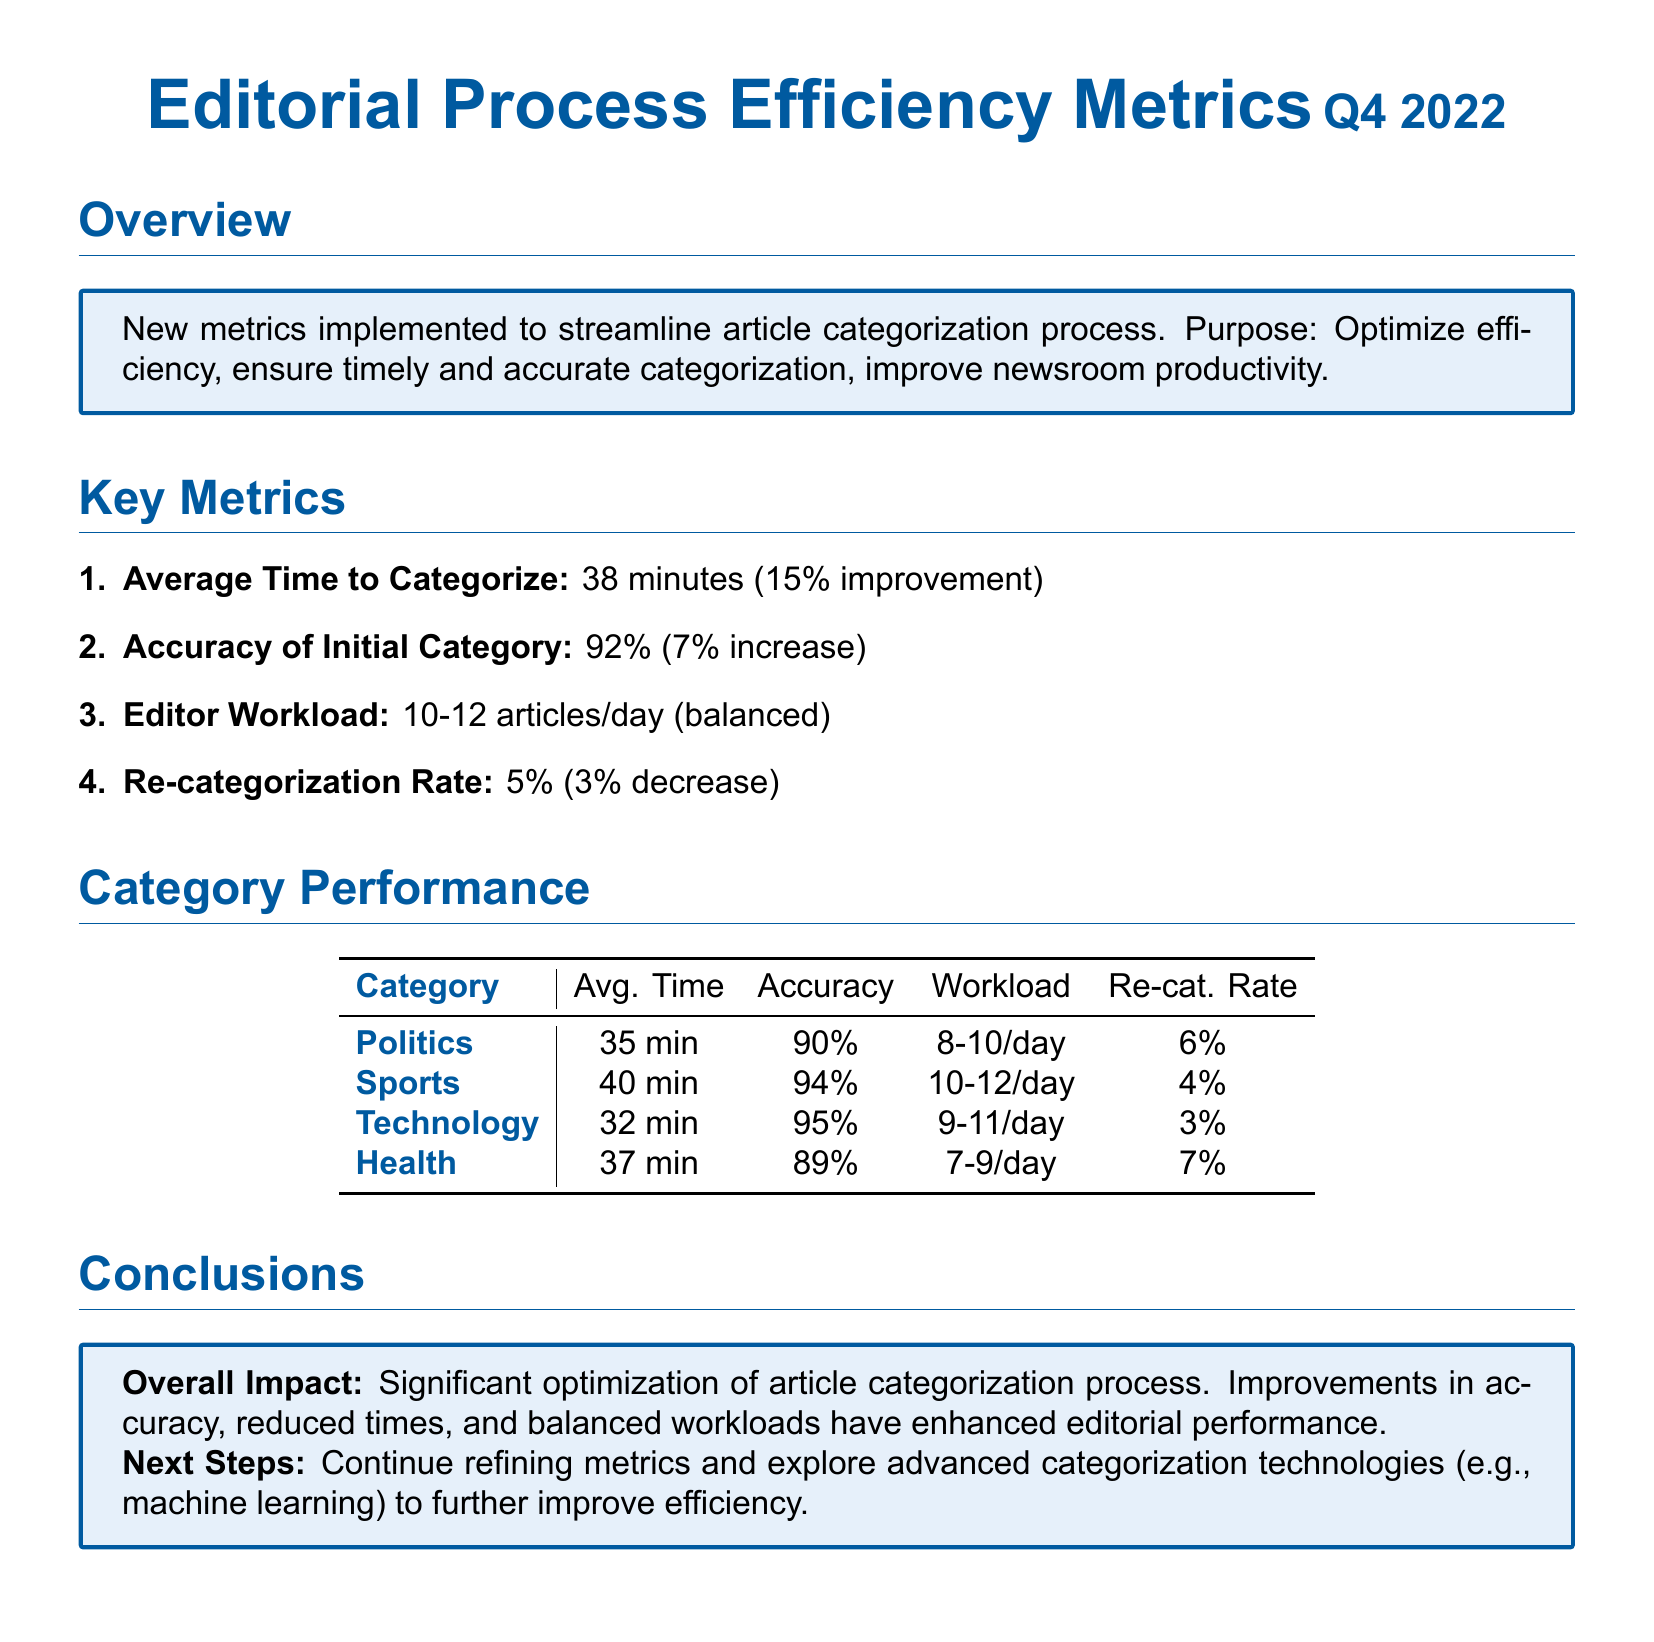What is the average time to categorize an article? The average time to categorize is provided in the key metrics section, which states 38 minutes.
Answer: 38 minutes What is the accuracy of the initial category? The accuracy of the initial category can be found in the key metrics section, indicating a 92% accuracy.
Answer: 92% What is the re-categorization rate? The re-categorization rate is mentioned in the key metrics section and is noted as 5%.
Answer: 5% Which category has the highest accuracy? To determine the category with the highest accuracy, we compare the accuracy values listed for each category in the performance table, revealing Technology at 95%.
Answer: Technology What is the average time for the Sports category? The average time for the Sports category can be found in the category performance table, which states 40 minutes.
Answer: 40 minutes How many articles does an editor work on per day on average? The workload for editors is included in the key metrics, indicating a balanced workload of 10-12 articles per day.
Answer: 10-12 articles/day What is the conclusion about the overall impact? The conclusion section summarizes the overall impact as significant optimization, citing improvements made to the categorization process.
Answer: Significant optimization What is the reason for future steps mentioned in the conclusions? The document indicates that future steps focus on refining metrics and exploring advanced categorization technologies, reflecting an ongoing improvement strategy.
Answer: Advanced categorization technologies What percentage improvement was seen in the average time to categorize? The improvement in average time is listed in the key metrics as a 15% improvement.
Answer: 15% What is the average workload for the Technology category? The average workload for the Technology category is found in the category performance table, which states 9-11 articles/day.
Answer: 9-11 articles/day 